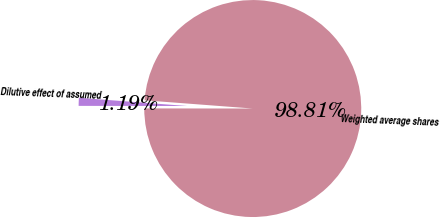Convert chart to OTSL. <chart><loc_0><loc_0><loc_500><loc_500><pie_chart><fcel>Weighted average shares<fcel>Dilutive effect of assumed<nl><fcel>98.81%<fcel>1.19%<nl></chart> 